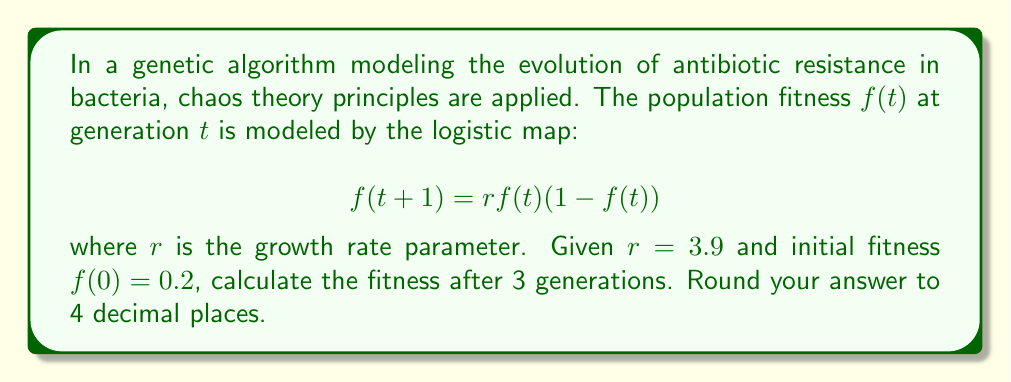What is the answer to this math problem? To solve this problem, we'll apply the logistic map equation iteratively for 3 generations:

1. Given: $r = 3.9$, $f(0) = 0.2$

2. For generation 1:
   $$f(1) = 3.9 \cdot 0.2 \cdot (1-0.2) = 3.9 \cdot 0.2 \cdot 0.8 = 0.624$$

3. For generation 2:
   $$f(2) = 3.9 \cdot 0.624 \cdot (1-0.624) = 3.9 \cdot 0.624 \cdot 0.376 = 0.9160896$$

4. For generation 3:
   $$f(3) = 3.9 \cdot 0.9160896 \cdot (1-0.9160896) = 3.9 \cdot 0.9160896 \cdot 0.0839104 = 0.3000$$

5. Rounding to 4 decimal places: 0.3000

This demonstrates how the fitness of the bacterial population changes chaotically over generations, which is relevant to the genetic algorithms used in modeling antibiotic resistance evolution.
Answer: 0.3000 